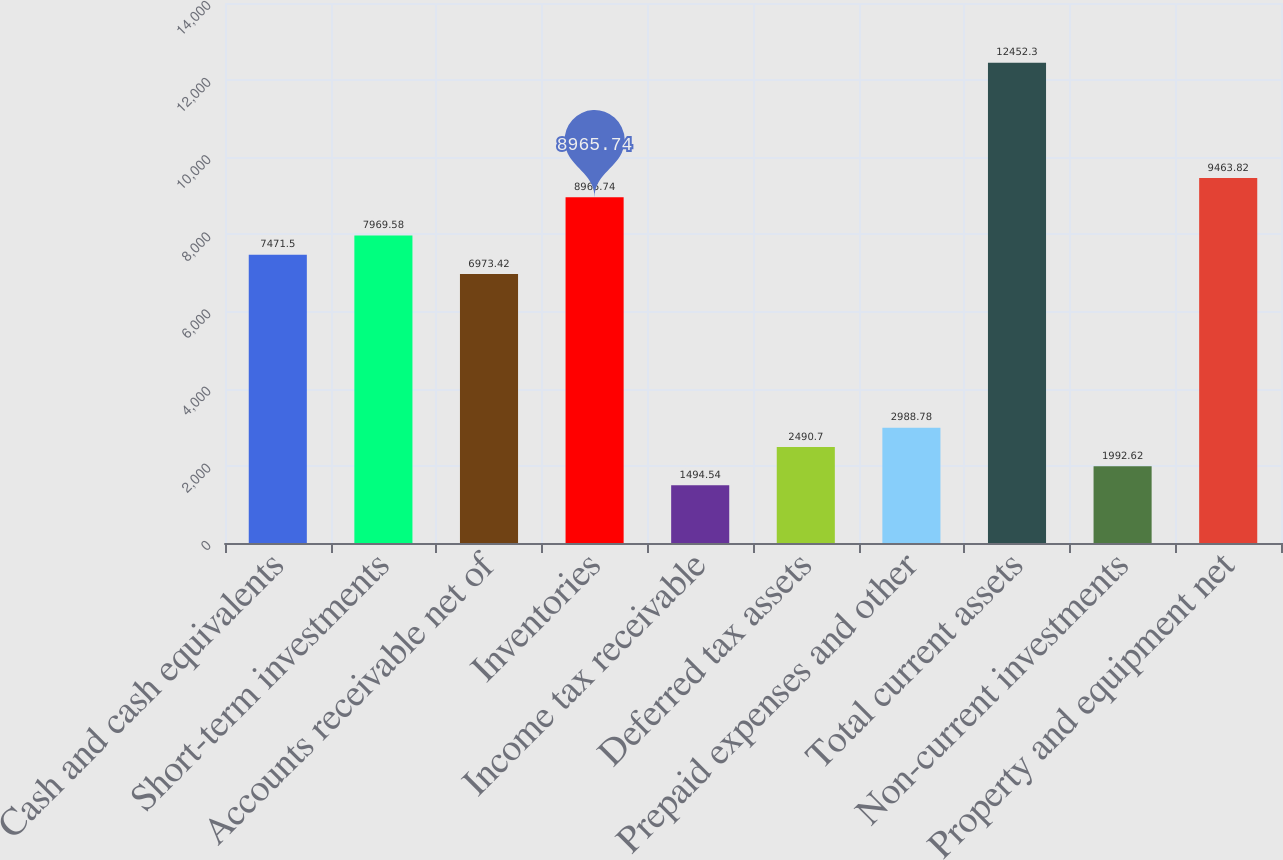<chart> <loc_0><loc_0><loc_500><loc_500><bar_chart><fcel>Cash and cash equivalents<fcel>Short-term investments<fcel>Accounts receivable net of<fcel>Inventories<fcel>Income tax receivable<fcel>Deferred tax assets<fcel>Prepaid expenses and other<fcel>Total current assets<fcel>Non-current investments<fcel>Property and equipment net<nl><fcel>7471.5<fcel>7969.58<fcel>6973.42<fcel>8965.74<fcel>1494.54<fcel>2490.7<fcel>2988.78<fcel>12452.3<fcel>1992.62<fcel>9463.82<nl></chart> 